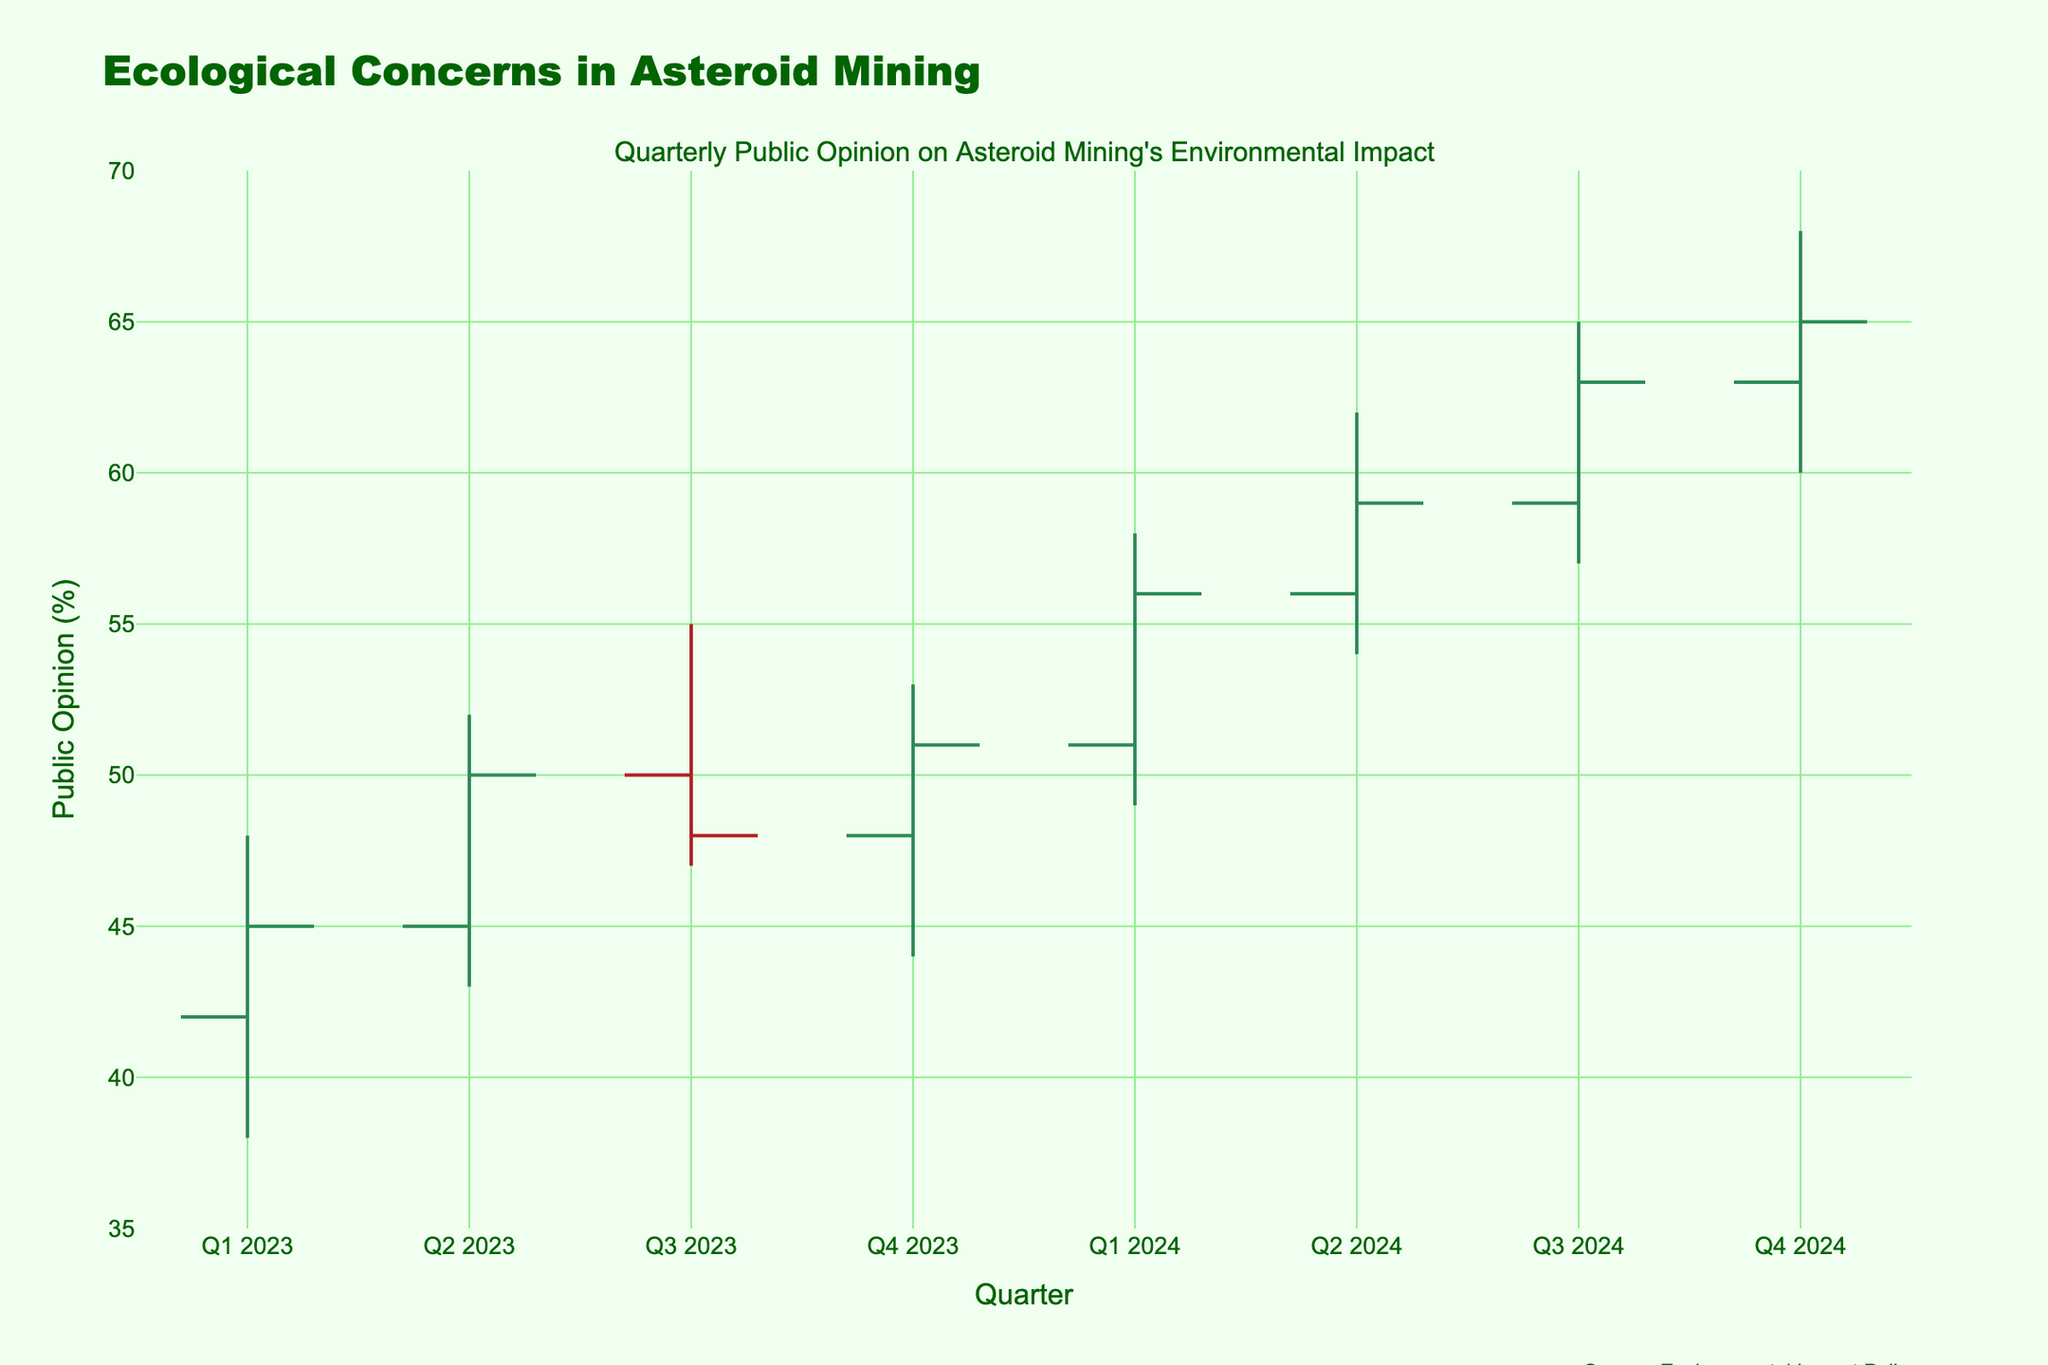What is the highest public opinion percentage recorded in the data? The highest public opinion percentage is found in the "High" column for each quarter. The highest value among these is 68, recorded in Q4 2024.
Answer: 68 What trend is noticeable when comparing the opening and closing percentages between Q2 2023 and Q3 2023? Comparing the "Open" and "Close" values for Q2 2023 (45, 50) and Q3 2023 (50, 48), the opening value increased from 45 to 50, while the closing value decreased from 50 to 48. Thus, the trend shows an initial rise followed by a slight decline.
Answer: Initial rise, slight decline Which quarter had the narrowest range in public opinion percentages? The range is calculated as the high minus the low for each quarter. The ranges are 10 for Q1 2023, 9 for Q2 2023, 8 for Q3 2023, 9 for Q4 2023, 9 for Q1 2024, 8 for Q2 2024, 8 for Q3 2024, and 8 for Q4 2024. The narrowest range is 8, observed in Q3 2023, Q2 2024, Q3 2024, and Q4 2024.
Answer: Q3 2023, Q2 2024, Q3 2024, Q4 2024 By how much did the closing percentage change from Q1 2023 to Q4 2024? The closing percentage in Q1 2023 was 45, and in Q4 2024, it was 65. The change is calculated as 65 - 45 = 20. Therefore, the closing percentage increased by 20 points.
Answer: Increased by 20 points Did any quarter close at a lower percentage than it opened? If so, which one(s)? We compare each quarter's "Open" and "Close" values. Only Q3 2023 has a closing value (48) lower than its opening value (50).
Answer: Q3 2023 What was the average closing percentage for the year 2024? The closing percentages for 2024 are: Q1 2024 (56), Q2 2024 (59), Q3 2024 (63), and Q4 2024 (65). The average is calculated as (56 + 59 + 63 + 65) / 4 = 60.75.
Answer: 60.75 What was the maximum decrease in public opinion within a single quarter? The maximum decrease can be found by comparing the "High" and "Low" values within each quarter. The largest difference is between 52 and 43 in Q2 2023, a decrease of 9 percentage points.
Answer: 9 percentage points Which quarter showed the greatest increase in closing percentage compared to the previous quarter? For each quarter, we calculate the difference in "Close" percentages: Q2 2023 (50 - 45 = 5), Q3 2023 (48 - 50 = -2), Q4 2023 (51 - 48 = 3), Q1 2024 (56 - 51 = 5), Q2 2024 (59 - 56 = 3), Q3 2024 (63 - 59 = 4), Q4 2024 (65 - 63 = 2). The greatest increase is 5 percentage points, seen in Q2 2023 and Q1 2024.
Answer: Q2 2023, Q1 2024 